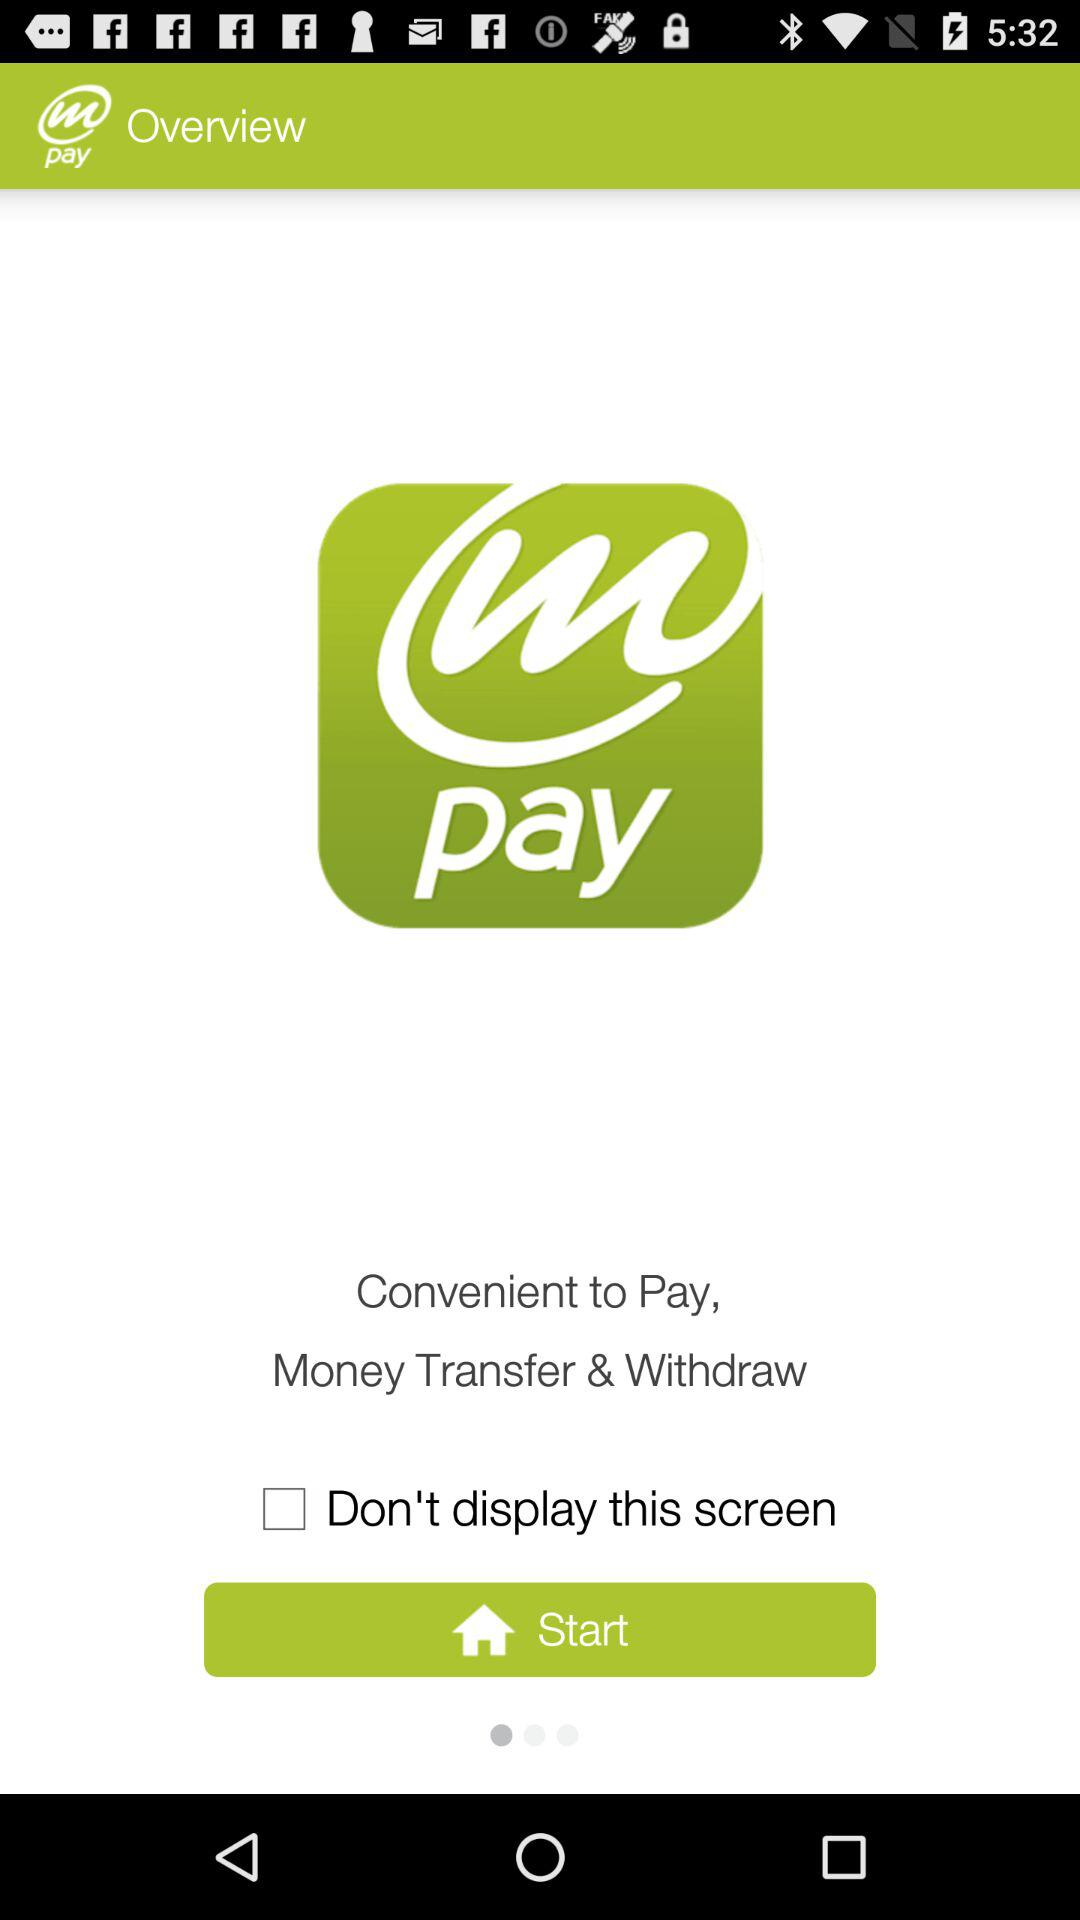What is the application name? The application name is "m pay". 